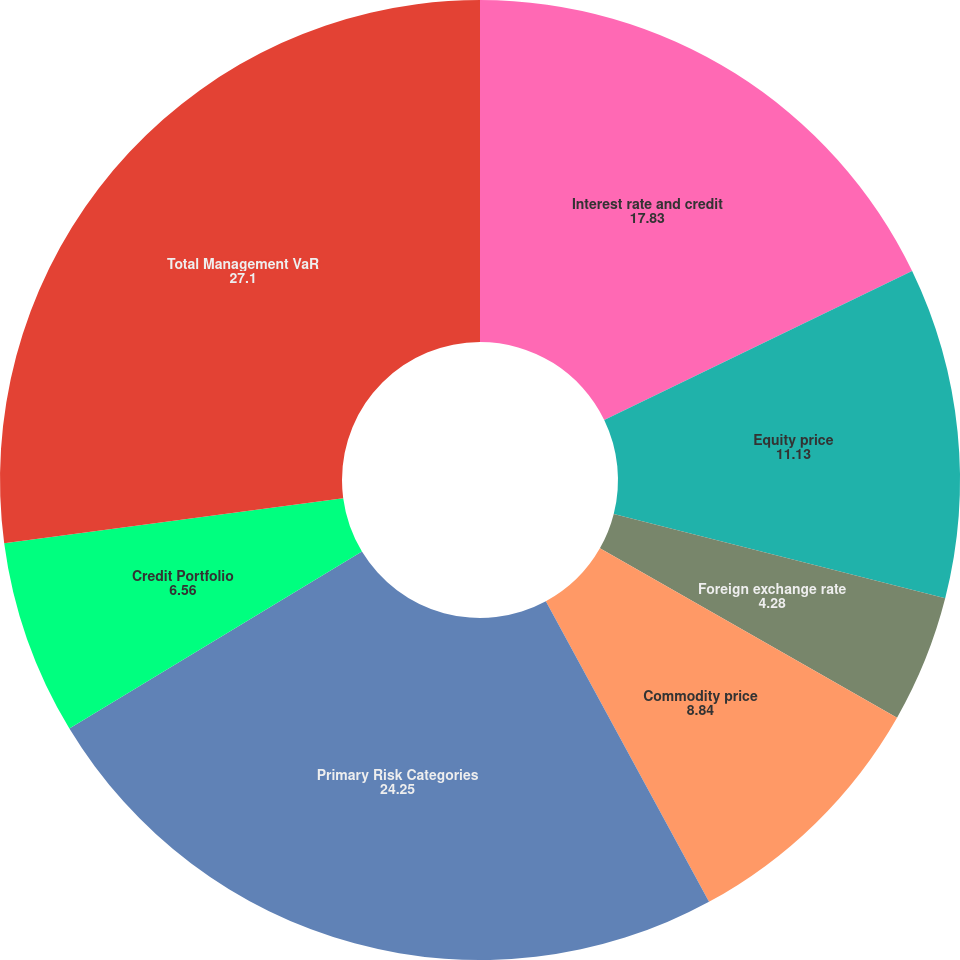Convert chart. <chart><loc_0><loc_0><loc_500><loc_500><pie_chart><fcel>Interest rate and credit<fcel>Equity price<fcel>Foreign exchange rate<fcel>Commodity price<fcel>Primary Risk Categories<fcel>Credit Portfolio<fcel>Total Management VaR<nl><fcel>17.83%<fcel>11.13%<fcel>4.28%<fcel>8.84%<fcel>24.25%<fcel>6.56%<fcel>27.1%<nl></chart> 